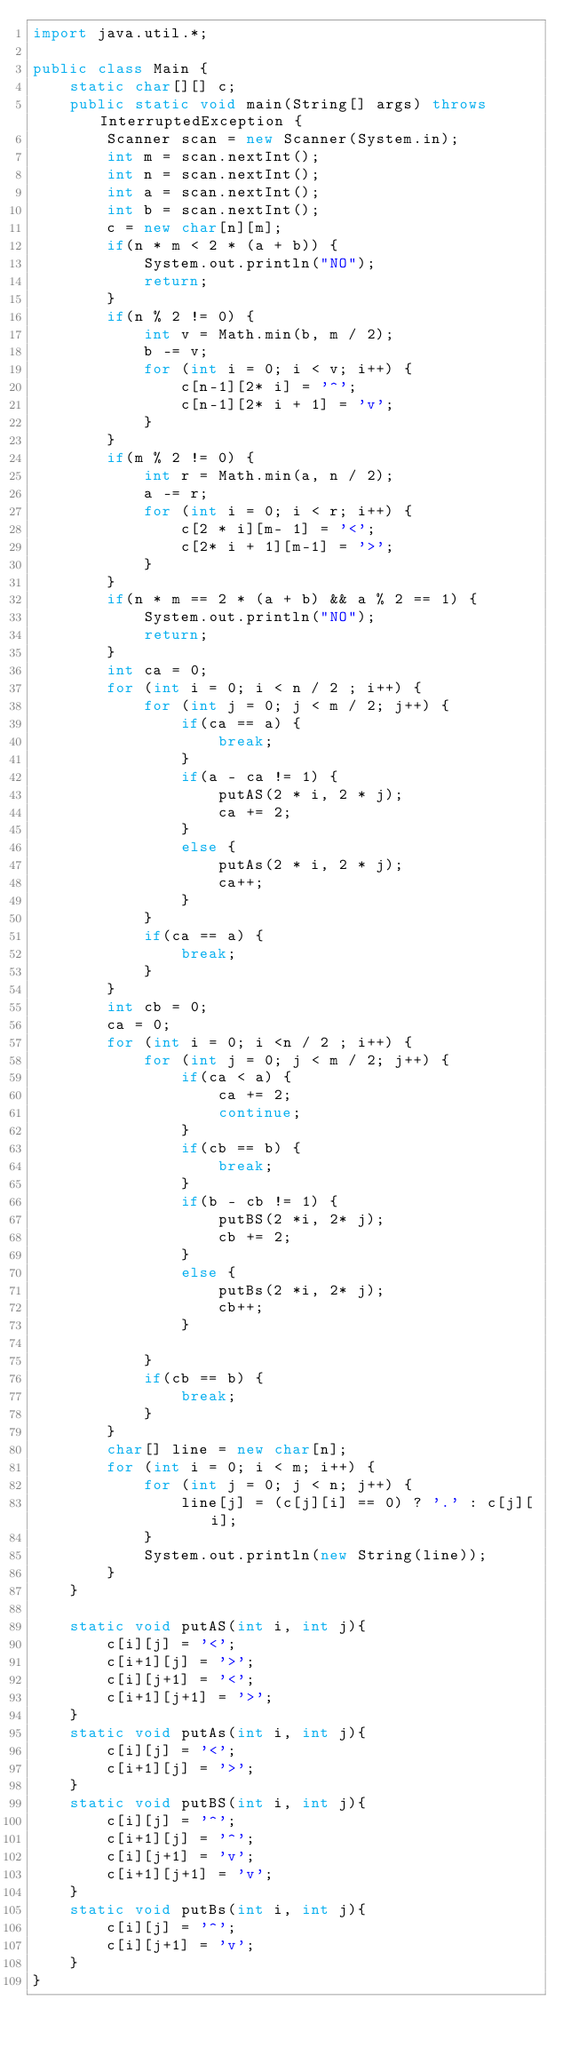Convert code to text. <code><loc_0><loc_0><loc_500><loc_500><_Java_>import java.util.*;

public class Main {
    static char[][] c;
    public static void main(String[] args) throws InterruptedException {
        Scanner scan = new Scanner(System.in);
        int m = scan.nextInt();
        int n = scan.nextInt();
        int a = scan.nextInt();
        int b = scan.nextInt();
        c = new char[n][m];
        if(n * m < 2 * (a + b)) {
            System.out.println("NO");
            return;
        }
        if(n % 2 != 0) {
            int v = Math.min(b, m / 2);
            b -= v;
            for (int i = 0; i < v; i++) {
                c[n-1][2* i] = '^';
                c[n-1][2* i + 1] = 'v';
            }
        }
        if(m % 2 != 0) {
            int r = Math.min(a, n / 2);
            a -= r;
            for (int i = 0; i < r; i++) {
                c[2 * i][m- 1] = '<';
                c[2* i + 1][m-1] = '>';
            }
        }
        if(n * m == 2 * (a + b) && a % 2 == 1) {
            System.out.println("NO");
            return;
        }
        int ca = 0;
        for (int i = 0; i < n / 2 ; i++) {
            for (int j = 0; j < m / 2; j++) {
                if(ca == a) {
                    break;
                }
                if(a - ca != 1) {
                    putAS(2 * i, 2 * j);
                    ca += 2;
                }
                else {
                    putAs(2 * i, 2 * j);
                    ca++;
                }
            }
            if(ca == a) {
                break;
            }
        }
        int cb = 0;
        ca = 0;
        for (int i = 0; i <n / 2 ; i++) {
            for (int j = 0; j < m / 2; j++) {
                if(ca < a) {
                    ca += 2;
                    continue;
                }
                if(cb == b) {
                    break;
                }
                if(b - cb != 1) {
                    putBS(2 *i, 2* j);
                    cb += 2;
                }
                else {
                    putBs(2 *i, 2* j);
                    cb++;
                }

            }
            if(cb == b) {
                break;
            }
        }
        char[] line = new char[n];
        for (int i = 0; i < m; i++) {
            for (int j = 0; j < n; j++) {
                line[j] = (c[j][i] == 0) ? '.' : c[j][i];
            }
            System.out.println(new String(line));
        }
    }

    static void putAS(int i, int j){
        c[i][j] = '<';
        c[i+1][j] = '>';
        c[i][j+1] = '<';
        c[i+1][j+1] = '>';
    }
    static void putAs(int i, int j){
        c[i][j] = '<';
        c[i+1][j] = '>';
    }
    static void putBS(int i, int j){
        c[i][j] = '^';
        c[i+1][j] = '^';
        c[i][j+1] = 'v';
        c[i+1][j+1] = 'v';
    }
    static void putBs(int i, int j){
        c[i][j] = '^';
        c[i][j+1] = 'v';
    }
}
</code> 